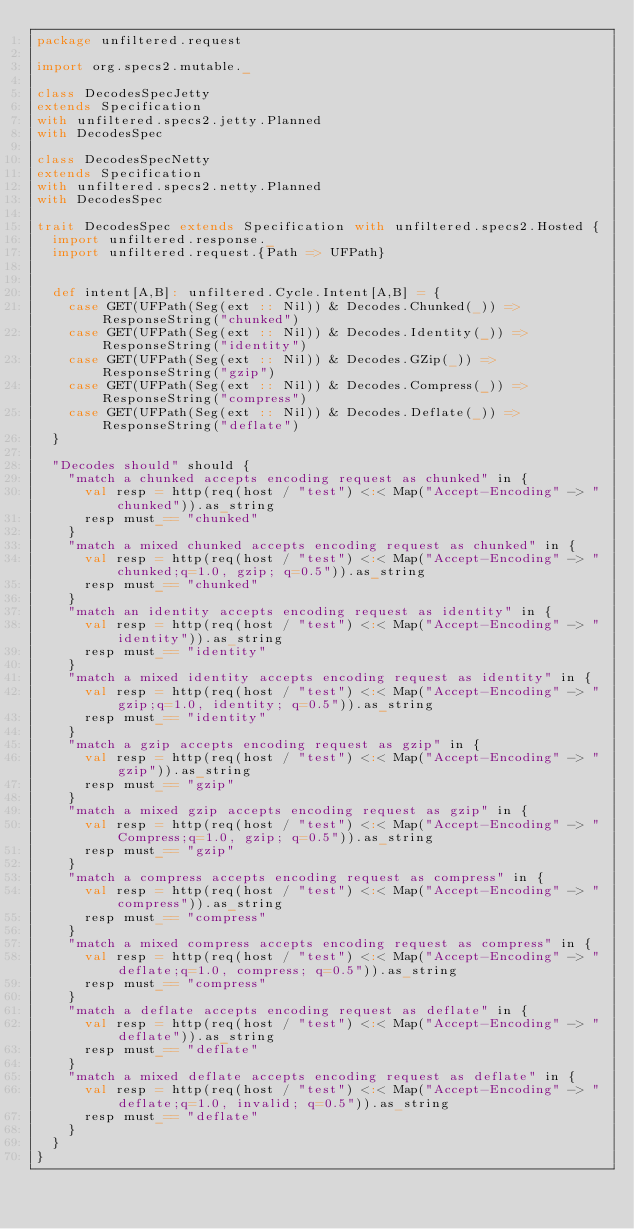<code> <loc_0><loc_0><loc_500><loc_500><_Scala_>package unfiltered.request

import org.specs2.mutable._

class DecodesSpecJetty
extends Specification
with unfiltered.specs2.jetty.Planned
with DecodesSpec

class DecodesSpecNetty
extends Specification
with unfiltered.specs2.netty.Planned
with DecodesSpec

trait DecodesSpec extends Specification with unfiltered.specs2.Hosted {
  import unfiltered.response._
  import unfiltered.request.{Path => UFPath}


  def intent[A,B]: unfiltered.Cycle.Intent[A,B] = {
    case GET(UFPath(Seg(ext :: Nil)) & Decodes.Chunked(_)) => ResponseString("chunked")
    case GET(UFPath(Seg(ext :: Nil)) & Decodes.Identity(_)) => ResponseString("identity")
    case GET(UFPath(Seg(ext :: Nil)) & Decodes.GZip(_)) => ResponseString("gzip")
    case GET(UFPath(Seg(ext :: Nil)) & Decodes.Compress(_)) => ResponseString("compress")
    case GET(UFPath(Seg(ext :: Nil)) & Decodes.Deflate(_)) => ResponseString("deflate")
  }

  "Decodes should" should {
    "match a chunked accepts encoding request as chunked" in {
      val resp = http(req(host / "test") <:< Map("Accept-Encoding" -> "chunked")).as_string
      resp must_== "chunked"
    }
    "match a mixed chunked accepts encoding request as chunked" in {
      val resp = http(req(host / "test") <:< Map("Accept-Encoding" -> "chunked;q=1.0, gzip; q=0.5")).as_string
      resp must_== "chunked"
    }
    "match an identity accepts encoding request as identity" in {
      val resp = http(req(host / "test") <:< Map("Accept-Encoding" -> "identity")).as_string
      resp must_== "identity"
    }
    "match a mixed identity accepts encoding request as identity" in {
      val resp = http(req(host / "test") <:< Map("Accept-Encoding" -> "gzip;q=1.0, identity; q=0.5")).as_string
      resp must_== "identity"
    }
    "match a gzip accepts encoding request as gzip" in {
      val resp = http(req(host / "test") <:< Map("Accept-Encoding" -> "gzip")).as_string
      resp must_== "gzip"
    }
    "match a mixed gzip accepts encoding request as gzip" in {
      val resp = http(req(host / "test") <:< Map("Accept-Encoding" -> "Compress;q=1.0, gzip; q=0.5")).as_string
      resp must_== "gzip"
    }
    "match a compress accepts encoding request as compress" in {
      val resp = http(req(host / "test") <:< Map("Accept-Encoding" -> "compress")).as_string
      resp must_== "compress"
    }
    "match a mixed compress accepts encoding request as compress" in {
      val resp = http(req(host / "test") <:< Map("Accept-Encoding" -> "deflate;q=1.0, compress; q=0.5")).as_string
      resp must_== "compress"
    }
    "match a deflate accepts encoding request as deflate" in {
      val resp = http(req(host / "test") <:< Map("Accept-Encoding" -> "deflate")).as_string
      resp must_== "deflate"
    }
    "match a mixed deflate accepts encoding request as deflate" in {
      val resp = http(req(host / "test") <:< Map("Accept-Encoding" -> "deflate;q=1.0, invalid; q=0.5")).as_string
      resp must_== "deflate"
    }
  }
}
</code> 